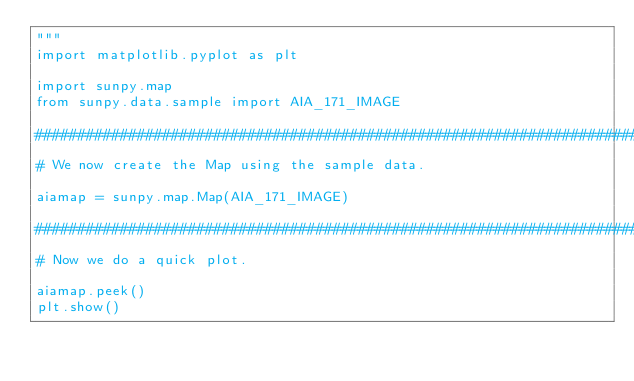<code> <loc_0><loc_0><loc_500><loc_500><_Python_>"""
import matplotlib.pyplot as plt

import sunpy.map
from sunpy.data.sample import AIA_171_IMAGE

###############################################################################
# We now create the Map using the sample data.

aiamap = sunpy.map.Map(AIA_171_IMAGE)

###############################################################################
# Now we do a quick plot.

aiamap.peek()
plt.show()
</code> 